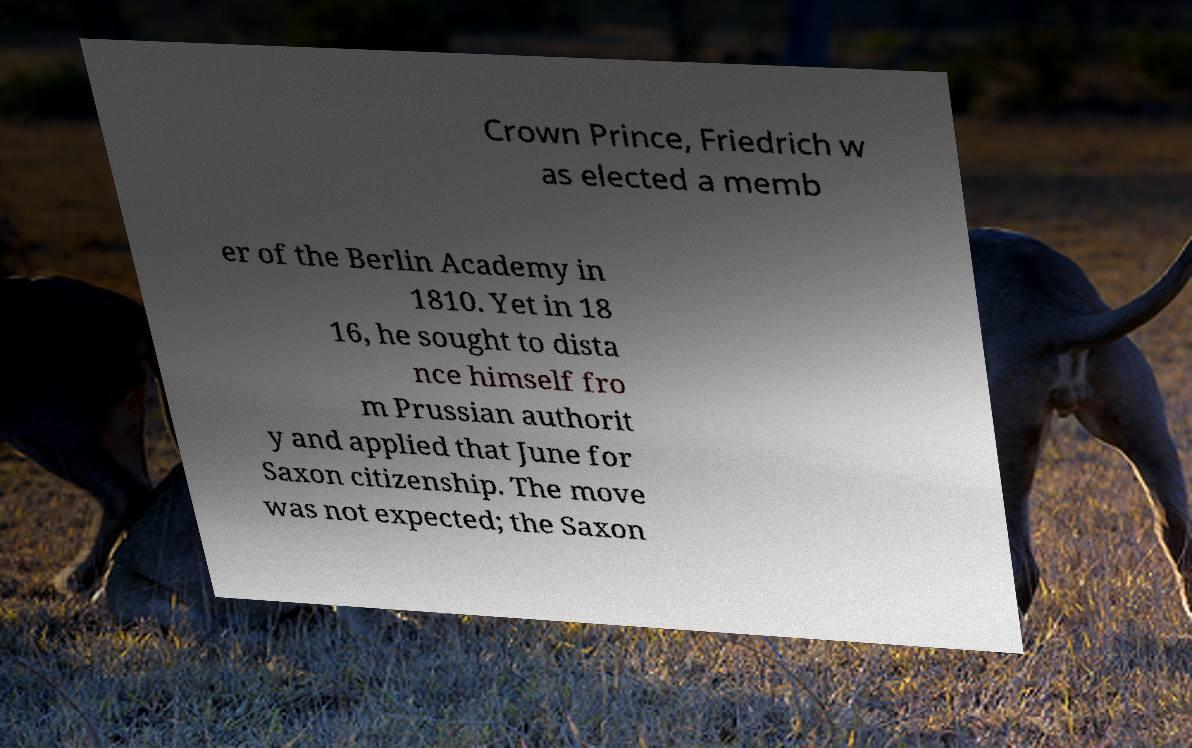I need the written content from this picture converted into text. Can you do that? Crown Prince, Friedrich w as elected a memb er of the Berlin Academy in 1810. Yet in 18 16, he sought to dista nce himself fro m Prussian authorit y and applied that June for Saxon citizenship. The move was not expected; the Saxon 